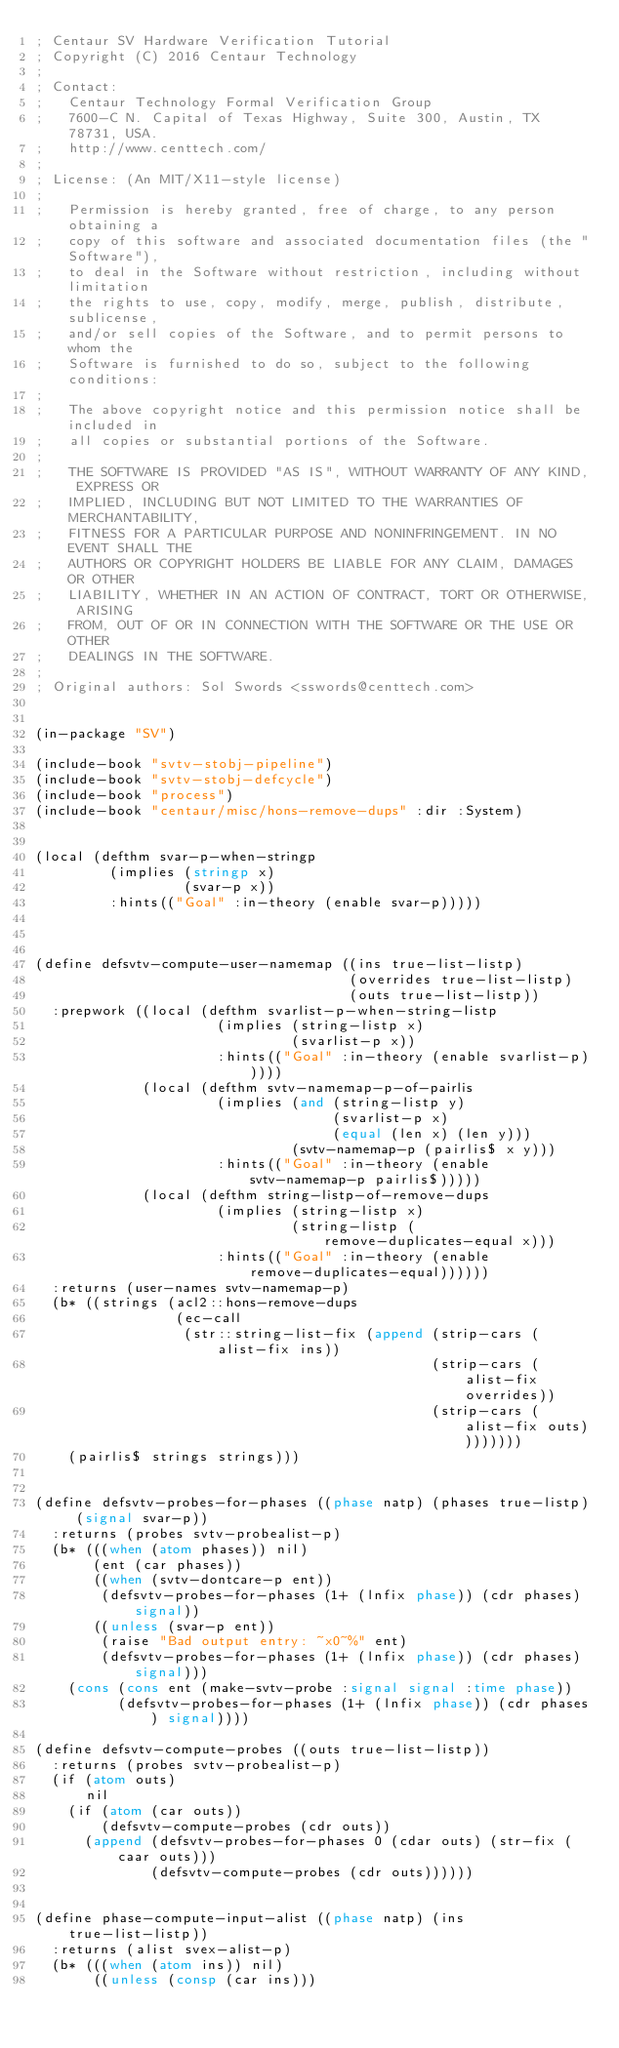Convert code to text. <code><loc_0><loc_0><loc_500><loc_500><_Lisp_>; Centaur SV Hardware Verification Tutorial
; Copyright (C) 2016 Centaur Technology
;
; Contact:
;   Centaur Technology Formal Verification Group
;   7600-C N. Capital of Texas Highway, Suite 300, Austin, TX 78731, USA.
;   http://www.centtech.com/
;
; License: (An MIT/X11-style license)
;
;   Permission is hereby granted, free of charge, to any person obtaining a
;   copy of this software and associated documentation files (the "Software"),
;   to deal in the Software without restriction, including without limitation
;   the rights to use, copy, modify, merge, publish, distribute, sublicense,
;   and/or sell copies of the Software, and to permit persons to whom the
;   Software is furnished to do so, subject to the following conditions:
;
;   The above copyright notice and this permission notice shall be included in
;   all copies or substantial portions of the Software.
;
;   THE SOFTWARE IS PROVIDED "AS IS", WITHOUT WARRANTY OF ANY KIND, EXPRESS OR
;   IMPLIED, INCLUDING BUT NOT LIMITED TO THE WARRANTIES OF MERCHANTABILITY,
;   FITNESS FOR A PARTICULAR PURPOSE AND NONINFRINGEMENT. IN NO EVENT SHALL THE
;   AUTHORS OR COPYRIGHT HOLDERS BE LIABLE FOR ANY CLAIM, DAMAGES OR OTHER
;   LIABILITY, WHETHER IN AN ACTION OF CONTRACT, TORT OR OTHERWISE, ARISING
;   FROM, OUT OF OR IN CONNECTION WITH THE SOFTWARE OR THE USE OR OTHER
;   DEALINGS IN THE SOFTWARE.
;
; Original authors: Sol Swords <sswords@centtech.com>


(in-package "SV")

(include-book "svtv-stobj-pipeline")
(include-book "svtv-stobj-defcycle")
(include-book "process")
(include-book "centaur/misc/hons-remove-dups" :dir :System)


(local (defthm svar-p-when-stringp
         (implies (stringp x)
                  (svar-p x))
         :hints(("Goal" :in-theory (enable svar-p)))))



(define defsvtv-compute-user-namemap ((ins true-list-listp)
                                      (overrides true-list-listp)
                                      (outs true-list-listp))
  :prepwork ((local (defthm svarlist-p-when-string-listp
                      (implies (string-listp x)
                               (svarlist-p x))
                      :hints(("Goal" :in-theory (enable svarlist-p)))))
             (local (defthm svtv-namemap-p-of-pairlis
                      (implies (and (string-listp y)
                                    (svarlist-p x)
                                    (equal (len x) (len y)))
                               (svtv-namemap-p (pairlis$ x y)))
                      :hints(("Goal" :in-theory (enable svtv-namemap-p pairlis$)))))
             (local (defthm string-listp-of-remove-dups
                      (implies (string-listp x)
                               (string-listp (remove-duplicates-equal x)))
                      :hints(("Goal" :in-theory (enable remove-duplicates-equal))))))
  :returns (user-names svtv-namemap-p)
  (b* ((strings (acl2::hons-remove-dups
                 (ec-call
                  (str::string-list-fix (append (strip-cars (alist-fix ins))
                                                (strip-cars (alist-fix overrides))
                                                (strip-cars (alist-fix outs))))))))
    (pairlis$ strings strings)))


(define defsvtv-probes-for-phases ((phase natp) (phases true-listp) (signal svar-p))
  :returns (probes svtv-probealist-p)
  (b* (((when (atom phases)) nil)
       (ent (car phases))
       ((when (svtv-dontcare-p ent))
        (defsvtv-probes-for-phases (1+ (lnfix phase)) (cdr phases) signal))
       ((unless (svar-p ent))
        (raise "Bad output entry: ~x0~%" ent)
        (defsvtv-probes-for-phases (1+ (lnfix phase)) (cdr phases) signal)))
    (cons (cons ent (make-svtv-probe :signal signal :time phase))
          (defsvtv-probes-for-phases (1+ (lnfix phase)) (cdr phases) signal))))

(define defsvtv-compute-probes ((outs true-list-listp))
  :returns (probes svtv-probealist-p)
  (if (atom outs)
      nil
    (if (atom (car outs))
        (defsvtv-compute-probes (cdr outs))
      (append (defsvtv-probes-for-phases 0 (cdar outs) (str-fix (caar outs)))
              (defsvtv-compute-probes (cdr outs))))))


(define phase-compute-input-alist ((phase natp) (ins true-list-listp))
  :returns (alist svex-alist-p)
  (b* (((when (atom ins)) nil)
       ((unless (consp (car ins)))</code> 